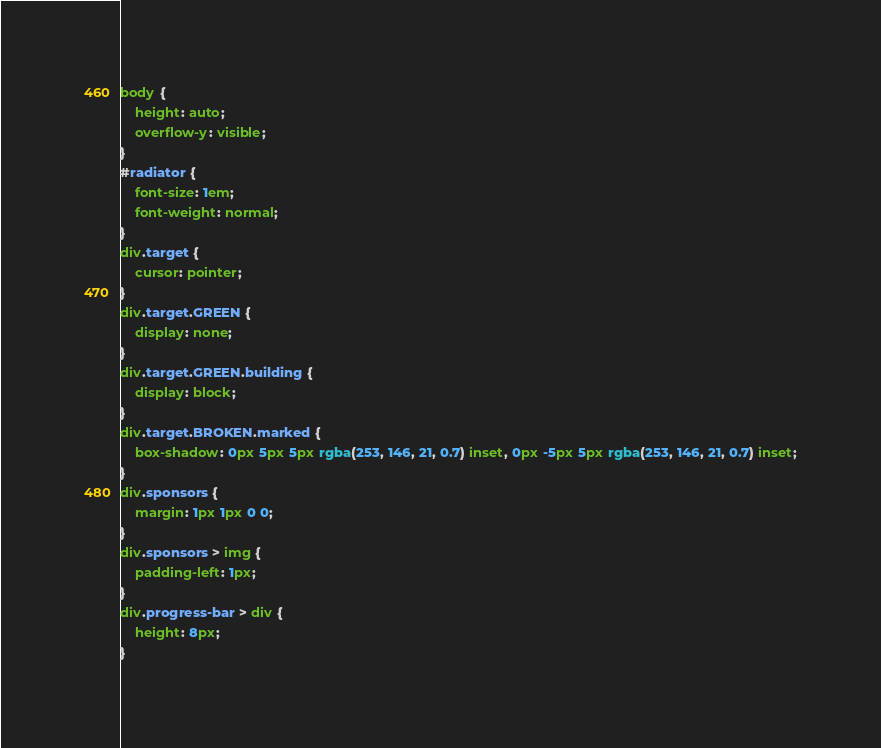<code> <loc_0><loc_0><loc_500><loc_500><_CSS_>body {
    height: auto;
    overflow-y: visible;
}
#radiator {
    font-size: 1em;
    font-weight: normal;
}
div.target {
    cursor: pointer;
}
div.target.GREEN {
    display: none;
}
div.target.GREEN.building {
    display: block;
}
div.target.BROKEN.marked {
    box-shadow: 0px 5px 5px rgba(253, 146, 21, 0.7) inset, 0px -5px 5px rgba(253, 146, 21, 0.7) inset;
}
div.sponsors {
    margin: 1px 1px 0 0;
}
div.sponsors > img {
    padding-left: 1px;
}
div.progress-bar > div {
    height: 8px;
}</code> 